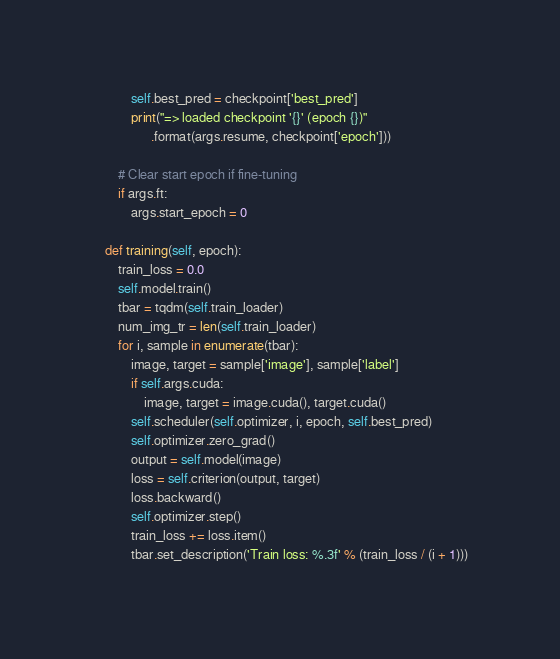<code> <loc_0><loc_0><loc_500><loc_500><_Python_>            self.best_pred = checkpoint['best_pred']
            print("=> loaded checkpoint '{}' (epoch {})"
                  .format(args.resume, checkpoint['epoch']))

        # Clear start epoch if fine-tuning
        if args.ft:
            args.start_epoch = 0

    def training(self, epoch):
        train_loss = 0.0
        self.model.train()
        tbar = tqdm(self.train_loader)
        num_img_tr = len(self.train_loader)
        for i, sample in enumerate(tbar):
            image, target = sample['image'], sample['label']
            if self.args.cuda:
                image, target = image.cuda(), target.cuda()
            self.scheduler(self.optimizer, i, epoch, self.best_pred)
            self.optimizer.zero_grad()
            output = self.model(image)
            loss = self.criterion(output, target)
            loss.backward()
            self.optimizer.step()
            train_loss += loss.item()
            tbar.set_description('Train loss: %.3f' % (train_loss / (i + 1)))</code> 